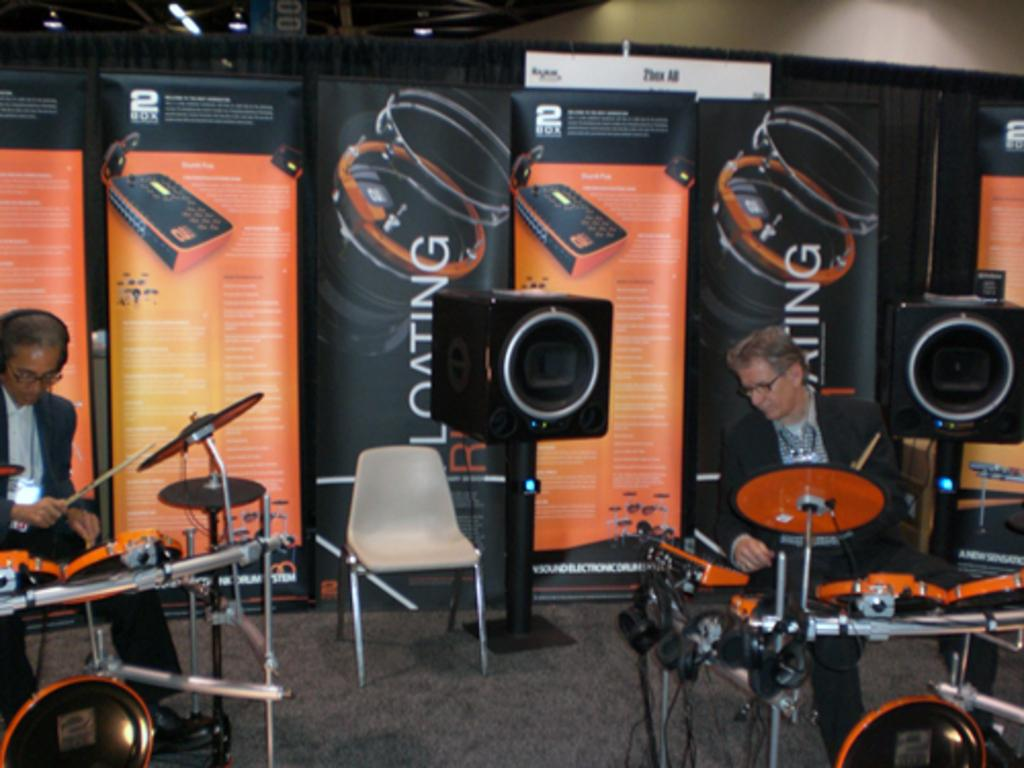What are the two persons in the image doing? The two persons in the image are playing drums. Can you describe their positions in the image? One person is on the left and the other is on the right. What can be observed about the person on the left? The person on the left is wearing glasses and headphones. What objects are present in the background of the image? There is a chair, two speakers, and a banner on the wall in the background. What type of ink is being used to write on the seat in the image? There is no seat or writing present in the image; it features two persons playing drums. How many stitches can be seen on the banner in the image? The banner in the image does not have any visible stitches. 